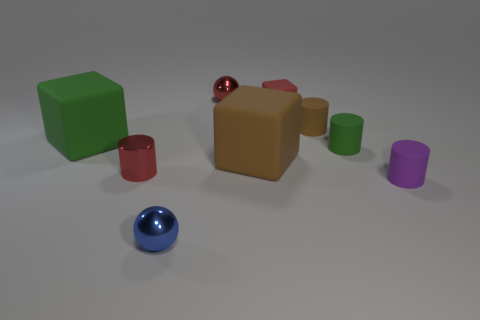Subtract all large cubes. How many cubes are left? 1 Subtract all red cubes. How many cubes are left? 2 Subtract 1 blocks. How many blocks are left? 2 Subtract all spheres. How many objects are left? 7 Subtract all blue cubes. How many gray spheres are left? 0 Subtract all large brown shiny balls. Subtract all green rubber objects. How many objects are left? 7 Add 8 tiny brown cylinders. How many tiny brown cylinders are left? 9 Add 6 large cubes. How many large cubes exist? 8 Subtract 0 gray blocks. How many objects are left? 9 Subtract all red cylinders. Subtract all brown spheres. How many cylinders are left? 3 